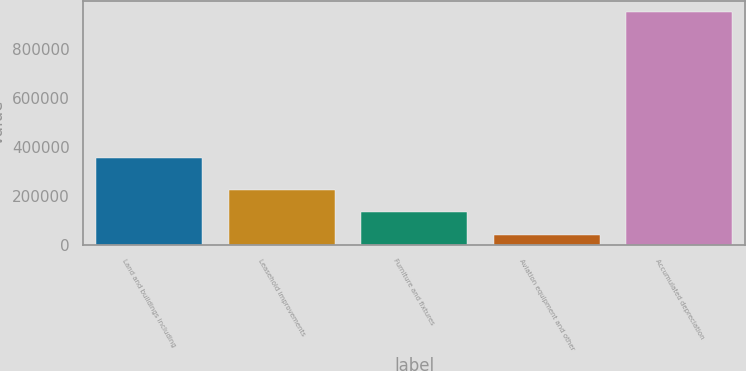<chart> <loc_0><loc_0><loc_500><loc_500><bar_chart><fcel>Land and buildings including<fcel>Leasehold improvements<fcel>Furniture and fixtures<fcel>Aviation equipment and other<fcel>Accumulated depreciation<nl><fcel>355222<fcel>222248<fcel>131542<fcel>40836<fcel>947894<nl></chart> 